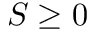<formula> <loc_0><loc_0><loc_500><loc_500>S \geq 0</formula> 